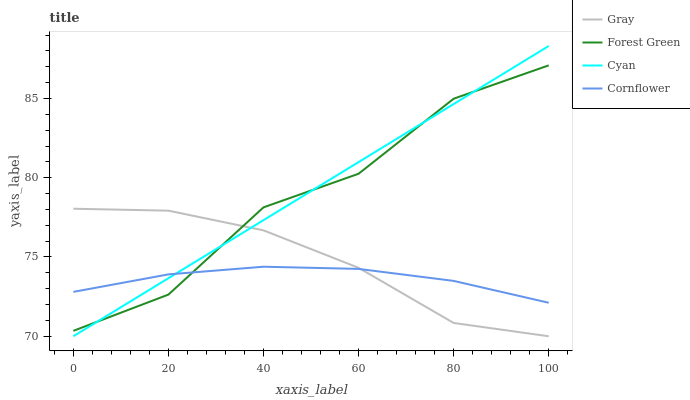Does Cornflower have the minimum area under the curve?
Answer yes or no. Yes. Does Cyan have the maximum area under the curve?
Answer yes or no. Yes. Does Forest Green have the minimum area under the curve?
Answer yes or no. No. Does Forest Green have the maximum area under the curve?
Answer yes or no. No. Is Cyan the smoothest?
Answer yes or no. Yes. Is Forest Green the roughest?
Answer yes or no. Yes. Is Cornflower the smoothest?
Answer yes or no. No. Is Cornflower the roughest?
Answer yes or no. No. Does Gray have the lowest value?
Answer yes or no. Yes. Does Forest Green have the lowest value?
Answer yes or no. No. Does Cyan have the highest value?
Answer yes or no. Yes. Does Forest Green have the highest value?
Answer yes or no. No. Does Cyan intersect Cornflower?
Answer yes or no. Yes. Is Cyan less than Cornflower?
Answer yes or no. No. Is Cyan greater than Cornflower?
Answer yes or no. No. 